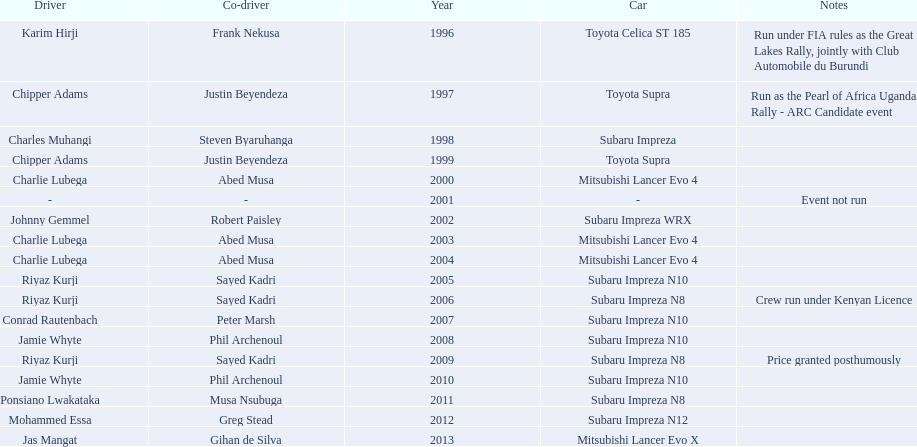Write the full table. {'header': ['Driver', 'Co-driver', 'Year', 'Car', 'Notes'], 'rows': [['Karim Hirji', 'Frank Nekusa', '1996', 'Toyota Celica ST 185', 'Run under FIA rules as the Great Lakes Rally, jointly with Club Automobile du Burundi'], ['Chipper Adams', 'Justin Beyendeza', '1997', 'Toyota Supra', 'Run as the Pearl of Africa Uganda Rally - ARC Candidate event'], ['Charles Muhangi', 'Steven Byaruhanga', '1998', 'Subaru Impreza', ''], ['Chipper Adams', 'Justin Beyendeza', '1999', 'Toyota Supra', ''], ['Charlie Lubega', 'Abed Musa', '2000', 'Mitsubishi Lancer Evo 4', ''], ['-', '-', '2001', '-', 'Event not run'], ['Johnny Gemmel', 'Robert Paisley', '2002', 'Subaru Impreza WRX', ''], ['Charlie Lubega', 'Abed Musa', '2003', 'Mitsubishi Lancer Evo 4', ''], ['Charlie Lubega', 'Abed Musa', '2004', 'Mitsubishi Lancer Evo 4', ''], ['Riyaz Kurji', 'Sayed Kadri', '2005', 'Subaru Impreza N10', ''], ['Riyaz Kurji', 'Sayed Kadri', '2006', 'Subaru Impreza N8', 'Crew run under Kenyan Licence'], ['Conrad Rautenbach', 'Peter Marsh', '2007', 'Subaru Impreza N10', ''], ['Jamie Whyte', 'Phil Archenoul', '2008', 'Subaru Impreza N10', ''], ['Riyaz Kurji', 'Sayed Kadri', '2009', 'Subaru Impreza N8', 'Price granted posthumously'], ['Jamie Whyte', 'Phil Archenoul', '2010', 'Subaru Impreza N10', ''], ['Ponsiano Lwakataka', 'Musa Nsubuga', '2011', 'Subaru Impreza N8', ''], ['Mohammed Essa', 'Greg Stead', '2012', 'Subaru Impreza N12', ''], ['Jas Mangat', 'Gihan de Silva', '2013', 'Mitsubishi Lancer Evo X', '']]} Who was the only driver to win in a car other than a subaru impreza after the year 2005? Jas Mangat. 